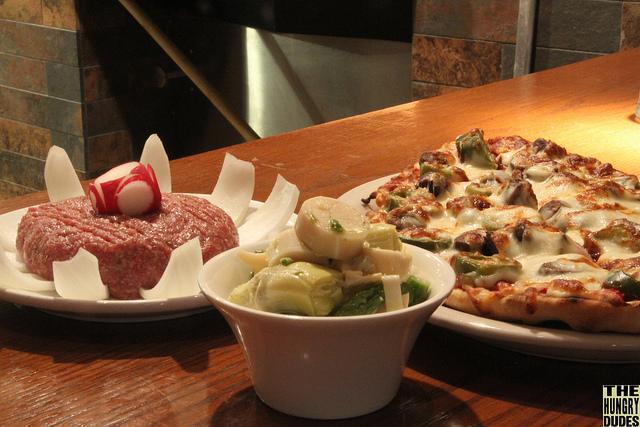How many bowls are in the picture?
Give a very brief answer. 1. How many people are wearing black pants?
Give a very brief answer. 0. 